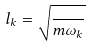<formula> <loc_0><loc_0><loc_500><loc_500>l _ { k } = \sqrt { \frac { } { m \omega _ { k } } }</formula> 